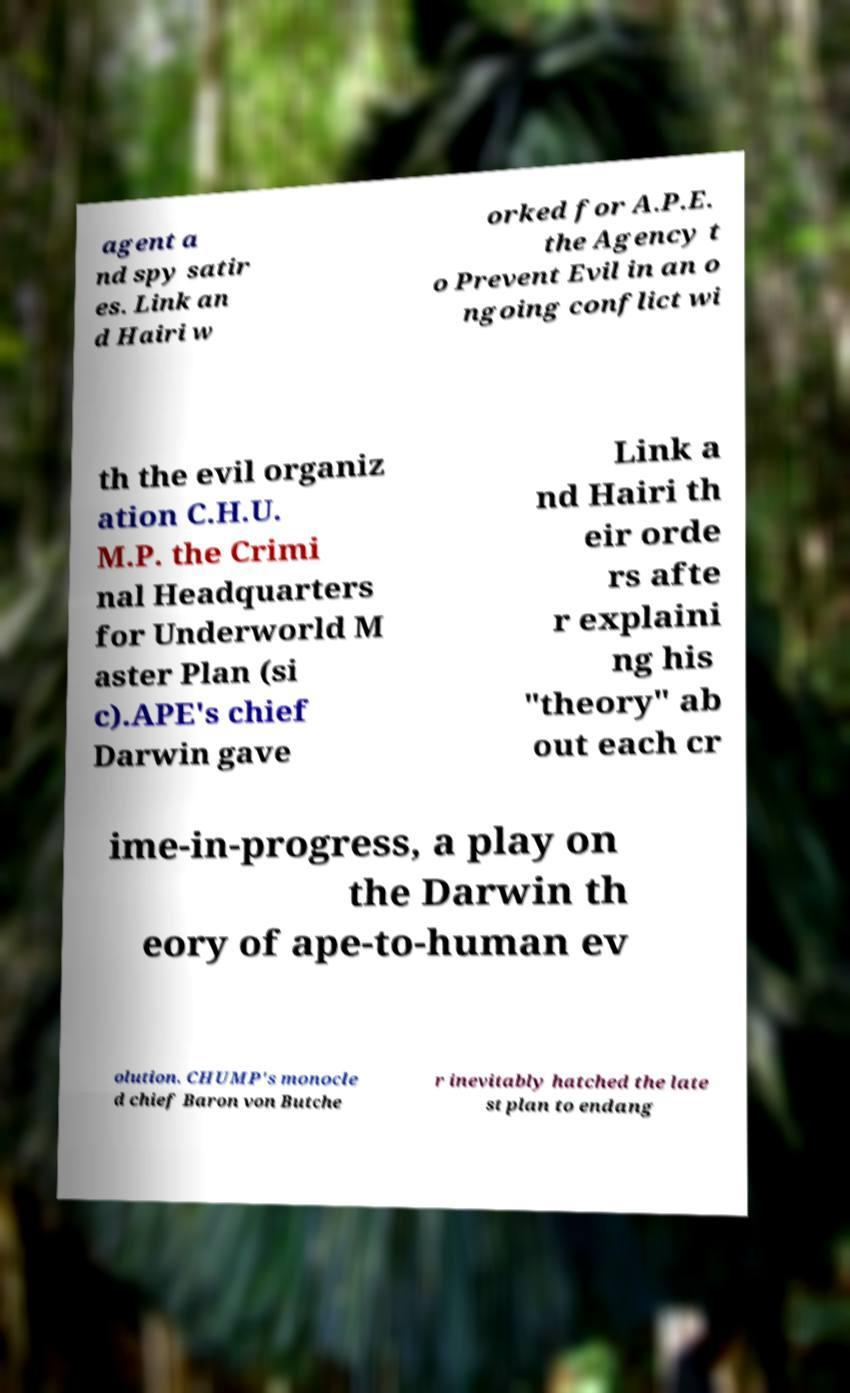I need the written content from this picture converted into text. Can you do that? agent a nd spy satir es. Link an d Hairi w orked for A.P.E. the Agency t o Prevent Evil in an o ngoing conflict wi th the evil organiz ation C.H.U. M.P. the Crimi nal Headquarters for Underworld M aster Plan (si c).APE's chief Darwin gave Link a nd Hairi th eir orde rs afte r explaini ng his "theory" ab out each cr ime-in-progress, a play on the Darwin th eory of ape-to-human ev olution. CHUMP's monocle d chief Baron von Butche r inevitably hatched the late st plan to endang 